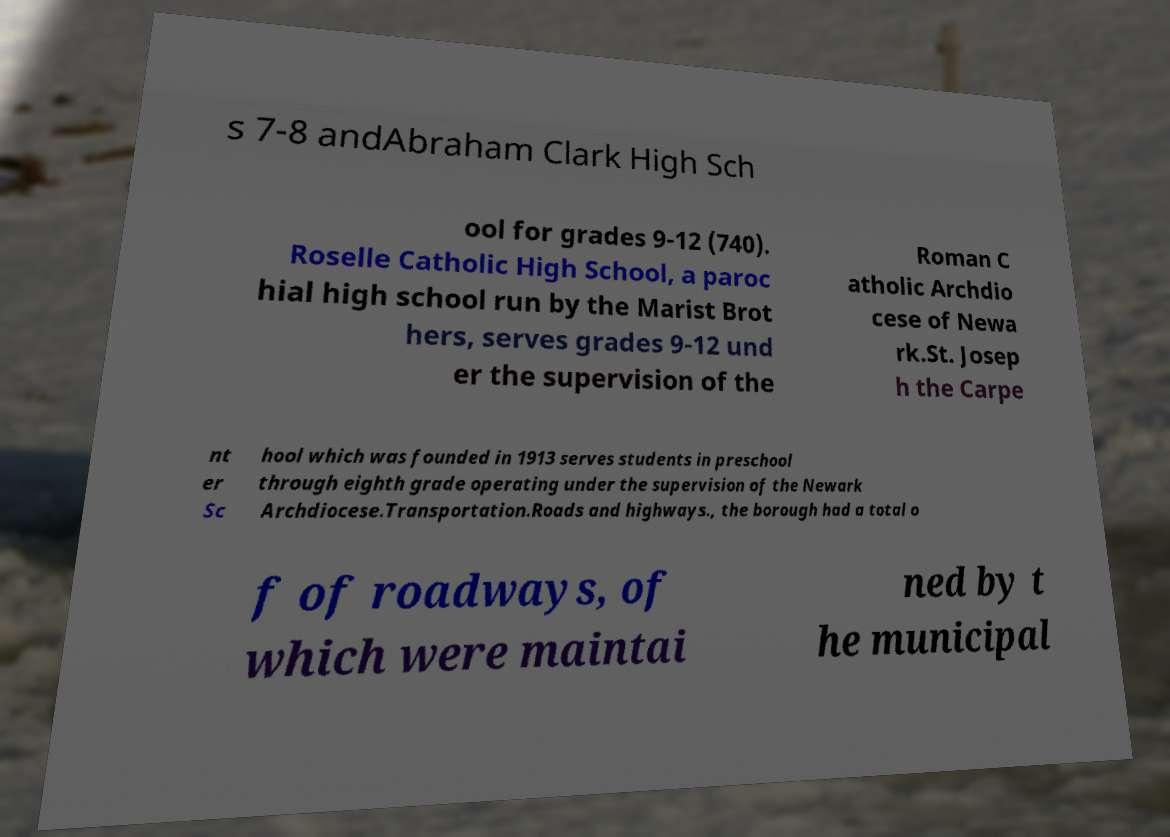Could you extract and type out the text from this image? s 7-8 andAbraham Clark High Sch ool for grades 9-12 (740). Roselle Catholic High School, a paroc hial high school run by the Marist Brot hers, serves grades 9-12 und er the supervision of the Roman C atholic Archdio cese of Newa rk.St. Josep h the Carpe nt er Sc hool which was founded in 1913 serves students in preschool through eighth grade operating under the supervision of the Newark Archdiocese.Transportation.Roads and highways., the borough had a total o f of roadways, of which were maintai ned by t he municipal 